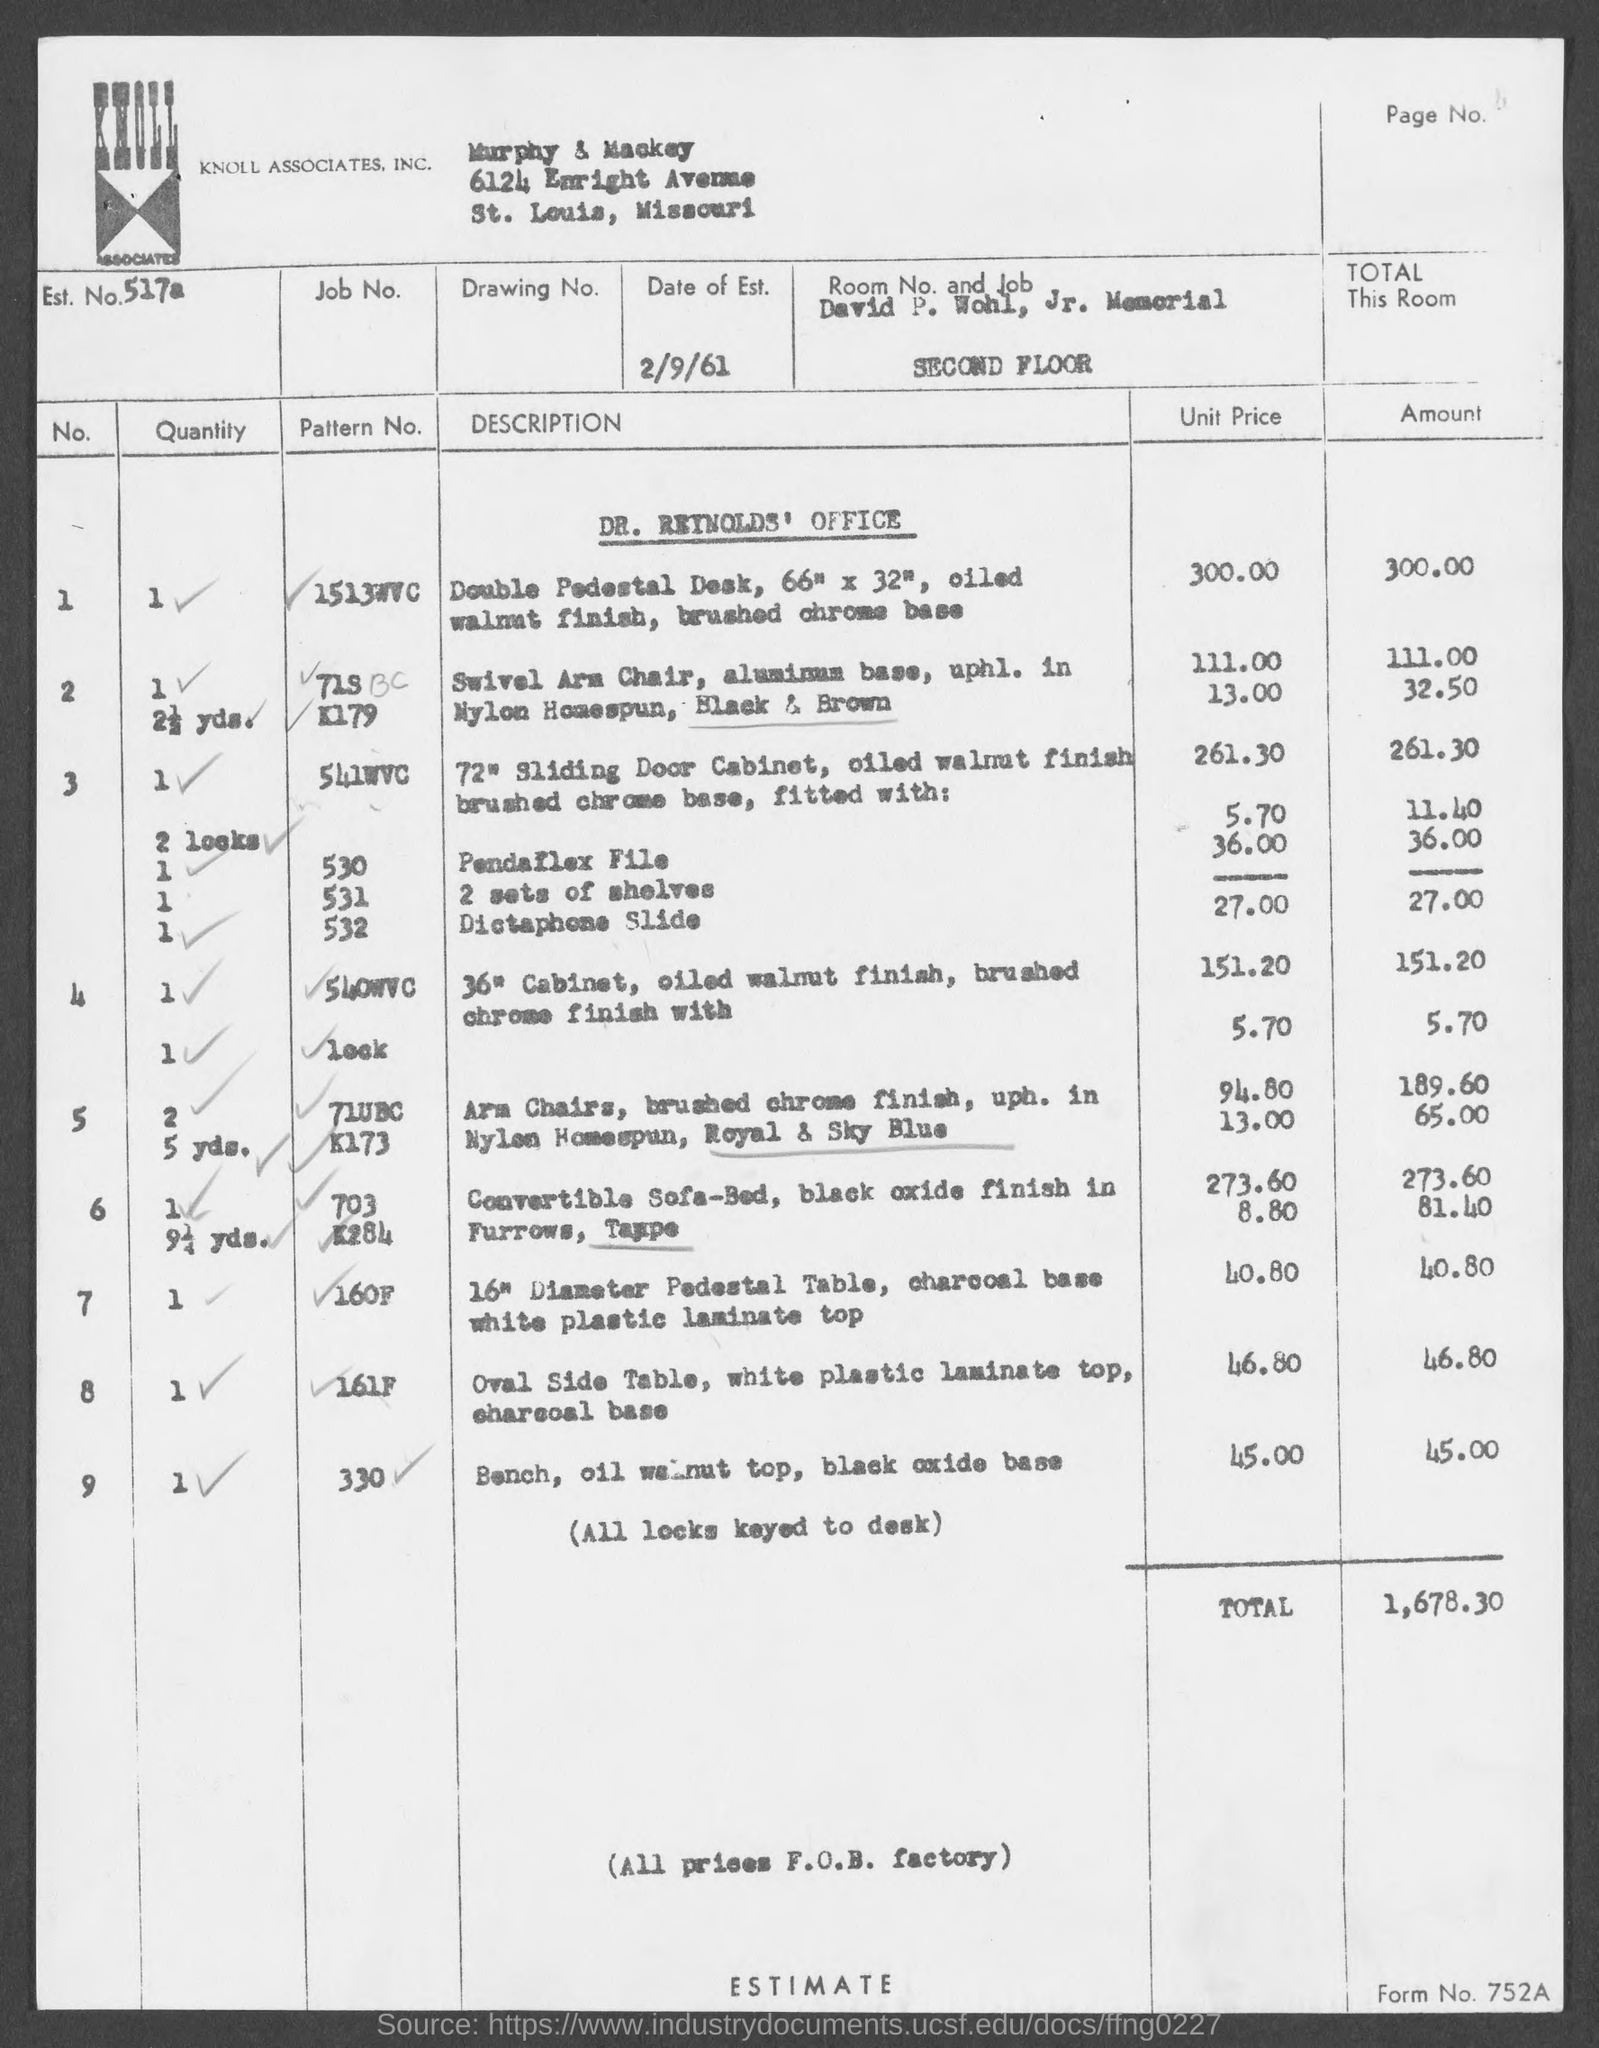What is the Est. No. given in the document?
Ensure brevity in your answer.  517a. What is the Date of Est. given in the document?
Ensure brevity in your answer.  2/9/61. What is the total estimated amount for Dr. Reynolds' Office?
Your answer should be very brief. 1,678.30. 